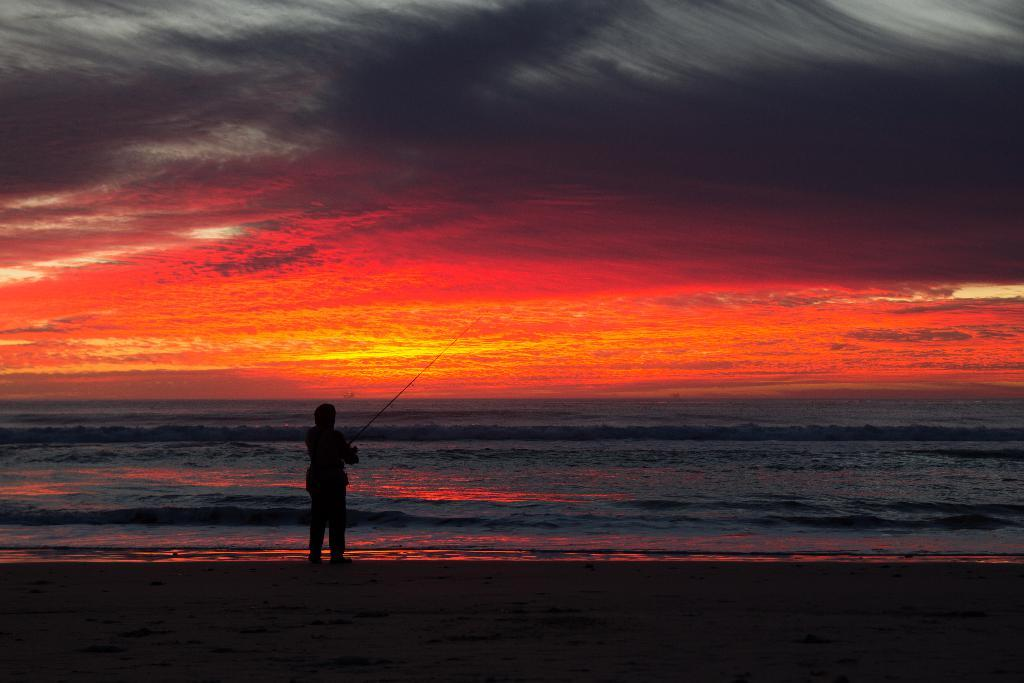What is the person in the image doing? The person is standing on the ground and holding a stick in their hands. What is the person standing near in the image? The person is standing near water. What can be seen in the background of the image? There is water visible in the background, and there are clouds in the sky. How many potatoes can be seen floating in the water in the image? There are no potatoes visible in the image; it features a person standing near water with a stick in their hands. 